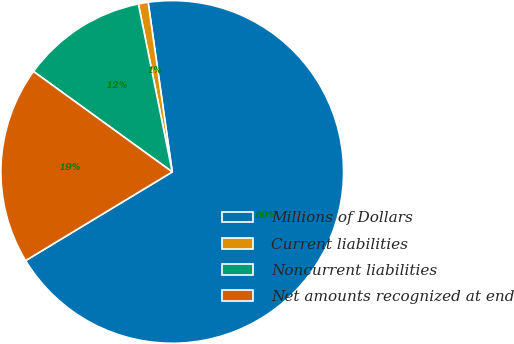<chart> <loc_0><loc_0><loc_500><loc_500><pie_chart><fcel>Millions of Dollars<fcel>Current liabilities<fcel>Noncurrent liabilities<fcel>Net amounts recognized at end<nl><fcel>68.58%<fcel>0.92%<fcel>11.86%<fcel>18.63%<nl></chart> 